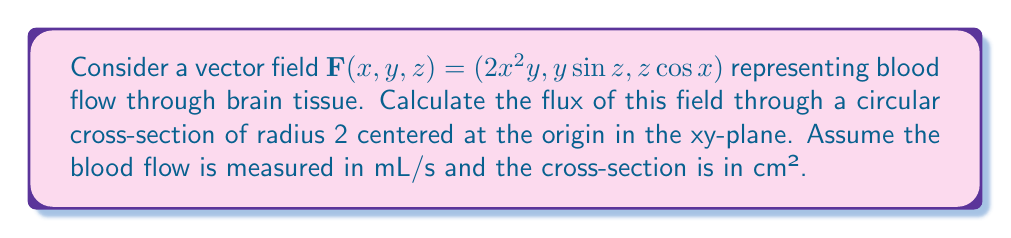Provide a solution to this math problem. To solve this problem, we'll follow these steps:

1) The flux of a vector field through a surface is given by the surface integral:

   $$ \iint_S \mathbf{F} \cdot d\mathbf{S} $$

2) For a surface in the xy-plane, the normal vector is in the z-direction, so $d\mathbf{S} = dxdy\hat{k}$.

3) The circular cross-section can be described as $x^2 + y^2 \leq 4$.

4) We only need the z-component of $\mathbf{F}$, which is $z\cos x$. However, since we're in the xy-plane, $z=0$, so this component becomes 0.

5) Therefore, the flux is zero regardless of the other components.

6) To verify, we can set up the integral:

   $$ \iint_S \mathbf{F} \cdot d\mathbf{S} = \iint_S z\cos x \, dxdy = \iint_S 0 \, dxdy = 0 $$

7) The area of integration doesn't matter because we're integrating zero everywhere.

8) Therefore, the flux of the blood flow through this cross-section is 0 mL/s.
Answer: 0 mL/s 